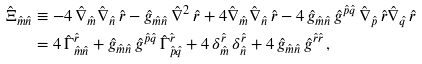<formula> <loc_0><loc_0><loc_500><loc_500>\hat { \Xi } _ { \hat { m } \hat { n } } & \equiv - 4 \, \hat { \nabla } _ { \hat { m } } \hat { \nabla } _ { \hat { n } } \, \hat { r } - \hat { g } _ { \hat { m } \hat { n } } \, \hat { \nabla } ^ { 2 } \, \hat { r } + 4 \hat { \nabla } _ { \hat { m } } \hat { \nabla } _ { \hat { n } } \, \hat { r } - 4 \, \hat { g } _ { \hat { m } \hat { n } } \, \hat { g } ^ { \hat { p } \hat { q } } \, \hat { \nabla } _ { \hat { p } } \, \hat { r } \hat { \nabla } _ { \hat { q } } \, \hat { r } \\ & = 4 \, \hat { \Gamma } ^ { \hat { r } } _ { \hat { m } \hat { n } } + \hat { g } _ { \hat { m } \hat { n } } \, \hat { g } ^ { \hat { p } \hat { q } } \, \hat { \Gamma } ^ { \hat { r } } _ { \hat { p } \hat { q } } + 4 \, \delta ^ { \hat { r } } _ { \hat { m } } \, \delta ^ { \hat { r } } _ { \hat { n } } + 4 \, \hat { g } _ { \hat { m } \hat { n } } \, \hat { g } ^ { \hat { r } \hat { r } } \, ,</formula> 